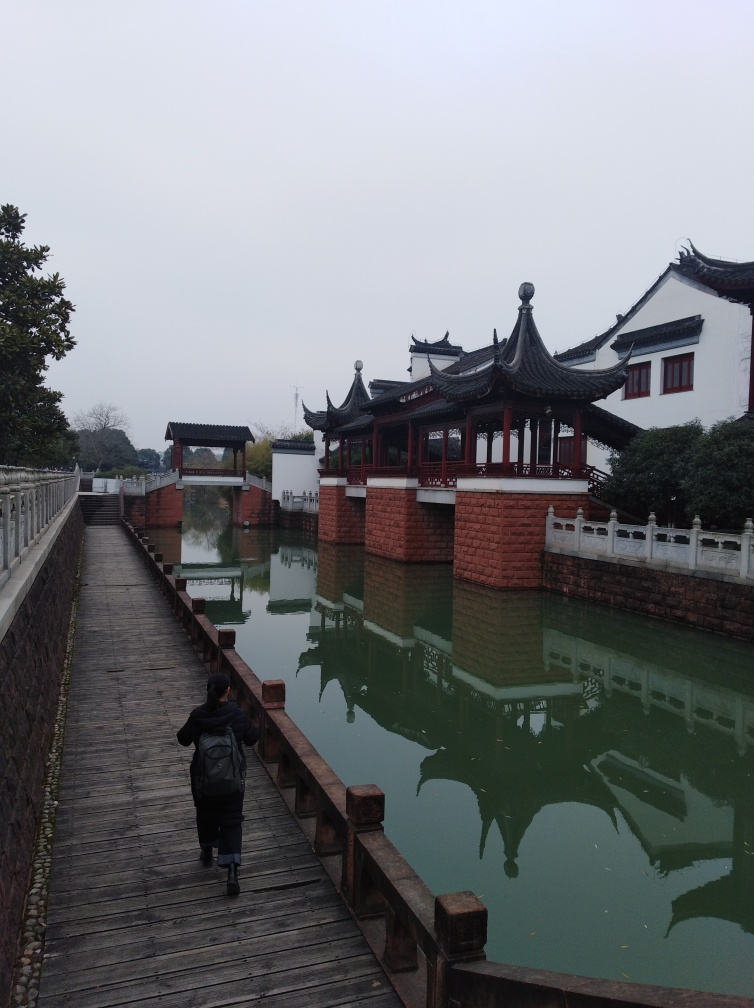Are there any signs of wildlife or nature in the image? While there are trees and a body of water, no wildlife is immediately visible in the image. However, the habitat suggests that birds or aquatic life could be present in the vicinity, perhaps not in view of the camera. The natural elements within the architecture's vicinity—like the well-maintained trees—add a touch of life to the otherwise still landscape. 